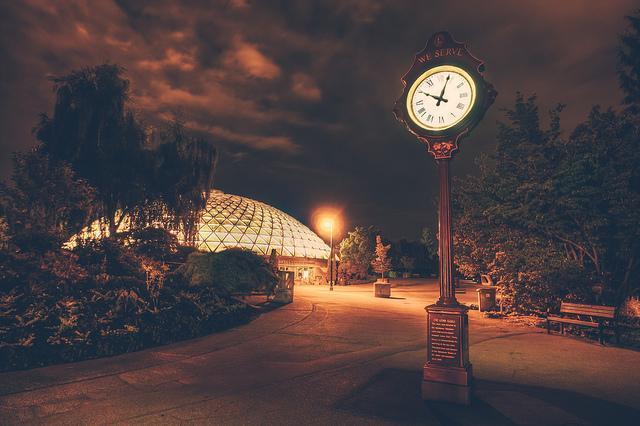How many clock faces are there?
Give a very brief answer. 1. 